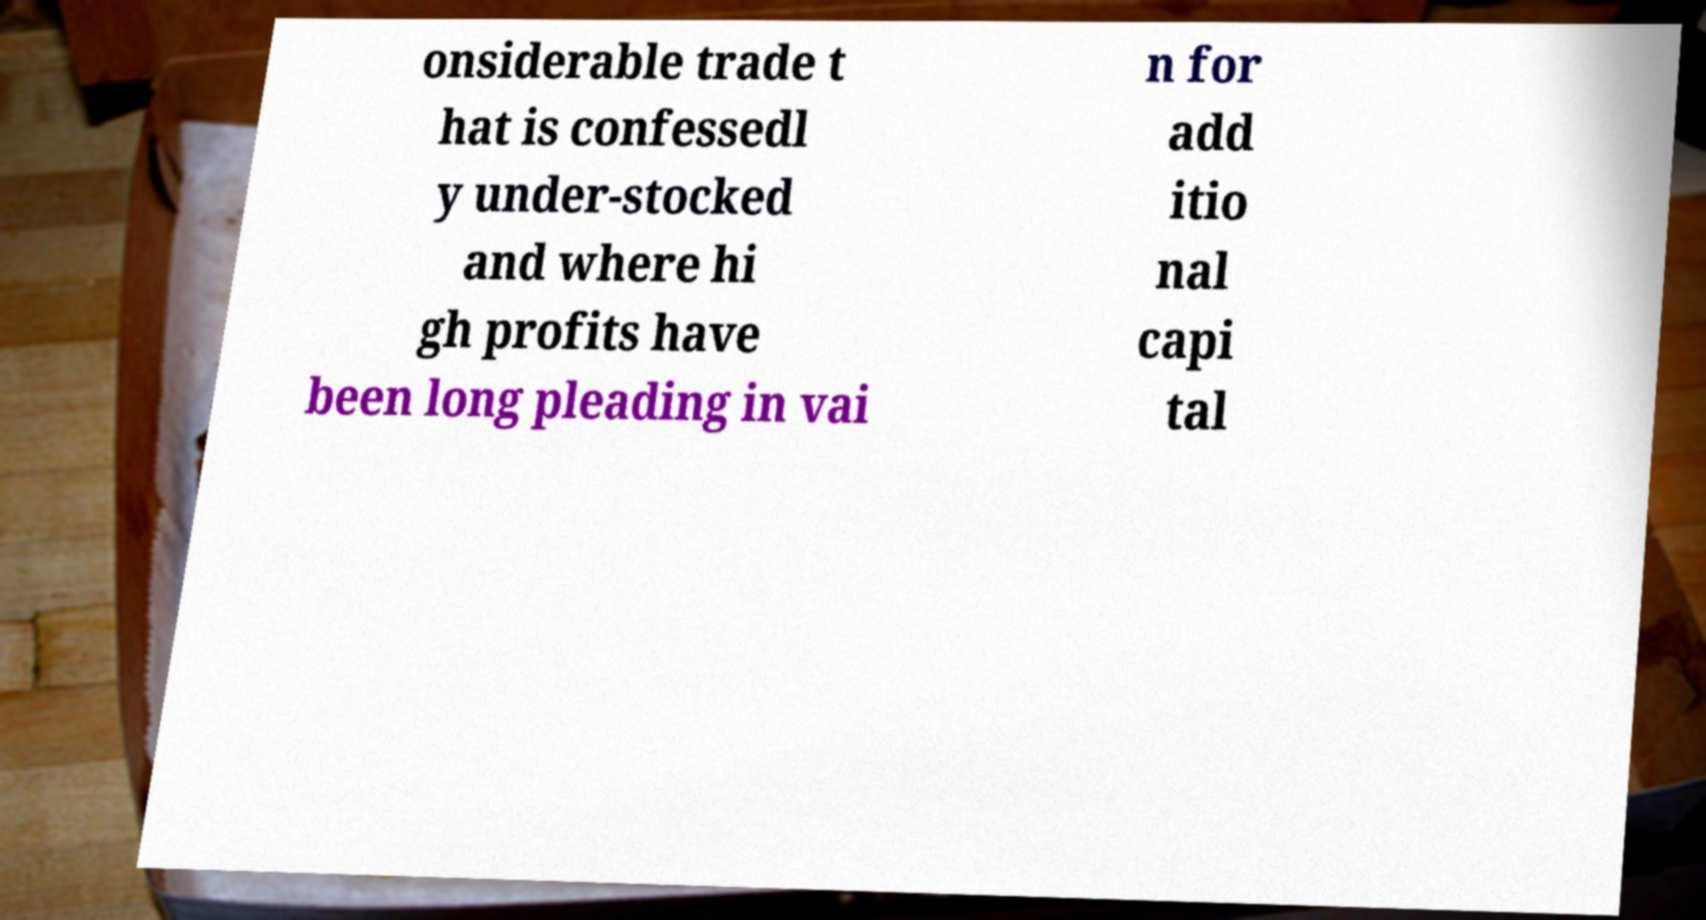I need the written content from this picture converted into text. Can you do that? onsiderable trade t hat is confessedl y under-stocked and where hi gh profits have been long pleading in vai n for add itio nal capi tal 